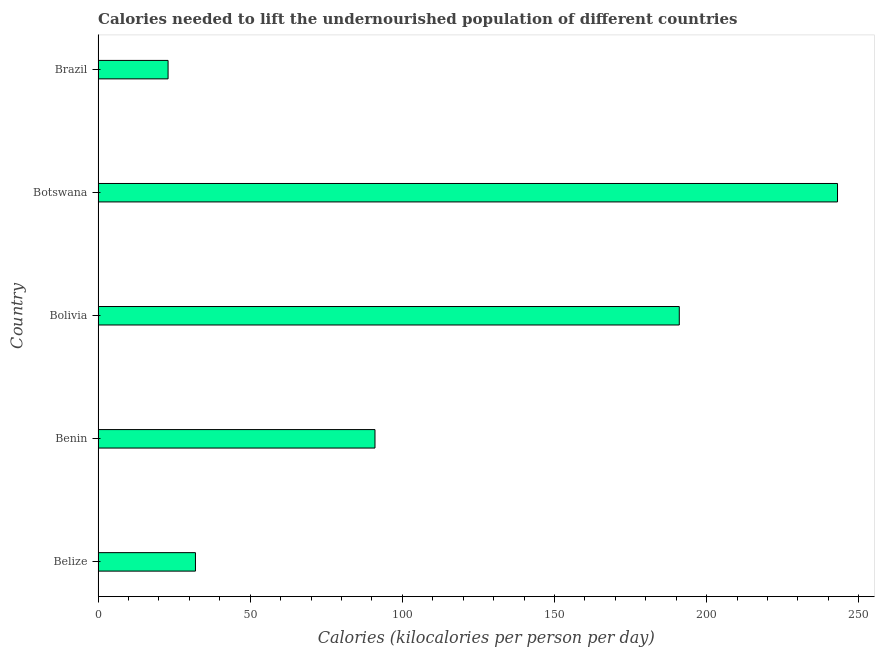Does the graph contain any zero values?
Offer a terse response. No. Does the graph contain grids?
Offer a very short reply. No. What is the title of the graph?
Make the answer very short. Calories needed to lift the undernourished population of different countries. What is the label or title of the X-axis?
Offer a terse response. Calories (kilocalories per person per day). What is the label or title of the Y-axis?
Ensure brevity in your answer.  Country. What is the depth of food deficit in Benin?
Give a very brief answer. 91. Across all countries, what is the maximum depth of food deficit?
Your answer should be compact. 243. Across all countries, what is the minimum depth of food deficit?
Your response must be concise. 23. In which country was the depth of food deficit maximum?
Provide a short and direct response. Botswana. What is the sum of the depth of food deficit?
Provide a succinct answer. 580. What is the difference between the depth of food deficit in Belize and Brazil?
Keep it short and to the point. 9. What is the average depth of food deficit per country?
Provide a short and direct response. 116. What is the median depth of food deficit?
Offer a terse response. 91. In how many countries, is the depth of food deficit greater than 190 kilocalories?
Give a very brief answer. 2. What is the ratio of the depth of food deficit in Botswana to that in Brazil?
Offer a very short reply. 10.56. Is the depth of food deficit in Belize less than that in Bolivia?
Your answer should be very brief. Yes. What is the difference between the highest and the second highest depth of food deficit?
Provide a short and direct response. 52. What is the difference between the highest and the lowest depth of food deficit?
Provide a short and direct response. 220. In how many countries, is the depth of food deficit greater than the average depth of food deficit taken over all countries?
Your answer should be compact. 2. How many bars are there?
Offer a terse response. 5. Are all the bars in the graph horizontal?
Give a very brief answer. Yes. What is the Calories (kilocalories per person per day) of Belize?
Make the answer very short. 32. What is the Calories (kilocalories per person per day) of Benin?
Offer a very short reply. 91. What is the Calories (kilocalories per person per day) in Bolivia?
Make the answer very short. 191. What is the Calories (kilocalories per person per day) of Botswana?
Offer a terse response. 243. What is the difference between the Calories (kilocalories per person per day) in Belize and Benin?
Offer a terse response. -59. What is the difference between the Calories (kilocalories per person per day) in Belize and Bolivia?
Offer a terse response. -159. What is the difference between the Calories (kilocalories per person per day) in Belize and Botswana?
Provide a short and direct response. -211. What is the difference between the Calories (kilocalories per person per day) in Belize and Brazil?
Offer a very short reply. 9. What is the difference between the Calories (kilocalories per person per day) in Benin and Bolivia?
Your answer should be very brief. -100. What is the difference between the Calories (kilocalories per person per day) in Benin and Botswana?
Provide a succinct answer. -152. What is the difference between the Calories (kilocalories per person per day) in Bolivia and Botswana?
Offer a terse response. -52. What is the difference between the Calories (kilocalories per person per day) in Bolivia and Brazil?
Give a very brief answer. 168. What is the difference between the Calories (kilocalories per person per day) in Botswana and Brazil?
Your answer should be very brief. 220. What is the ratio of the Calories (kilocalories per person per day) in Belize to that in Benin?
Ensure brevity in your answer.  0.35. What is the ratio of the Calories (kilocalories per person per day) in Belize to that in Bolivia?
Provide a short and direct response. 0.17. What is the ratio of the Calories (kilocalories per person per day) in Belize to that in Botswana?
Your answer should be very brief. 0.13. What is the ratio of the Calories (kilocalories per person per day) in Belize to that in Brazil?
Offer a terse response. 1.39. What is the ratio of the Calories (kilocalories per person per day) in Benin to that in Bolivia?
Your answer should be compact. 0.48. What is the ratio of the Calories (kilocalories per person per day) in Benin to that in Botswana?
Provide a succinct answer. 0.37. What is the ratio of the Calories (kilocalories per person per day) in Benin to that in Brazil?
Provide a short and direct response. 3.96. What is the ratio of the Calories (kilocalories per person per day) in Bolivia to that in Botswana?
Your answer should be compact. 0.79. What is the ratio of the Calories (kilocalories per person per day) in Bolivia to that in Brazil?
Make the answer very short. 8.3. What is the ratio of the Calories (kilocalories per person per day) in Botswana to that in Brazil?
Give a very brief answer. 10.56. 